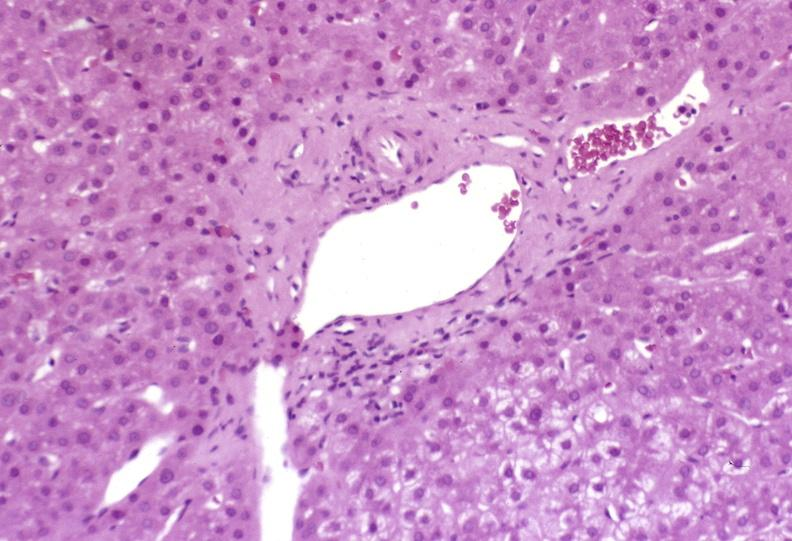s liver present?
Answer the question using a single word or phrase. Yes 